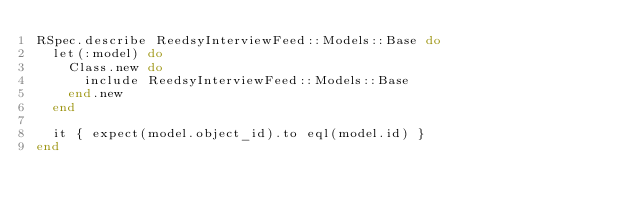Convert code to text. <code><loc_0><loc_0><loc_500><loc_500><_Ruby_>RSpec.describe ReedsyInterviewFeed::Models::Base do
  let(:model) do
    Class.new do
      include ReedsyInterviewFeed::Models::Base
    end.new
  end

  it { expect(model.object_id).to eql(model.id) }
end
</code> 